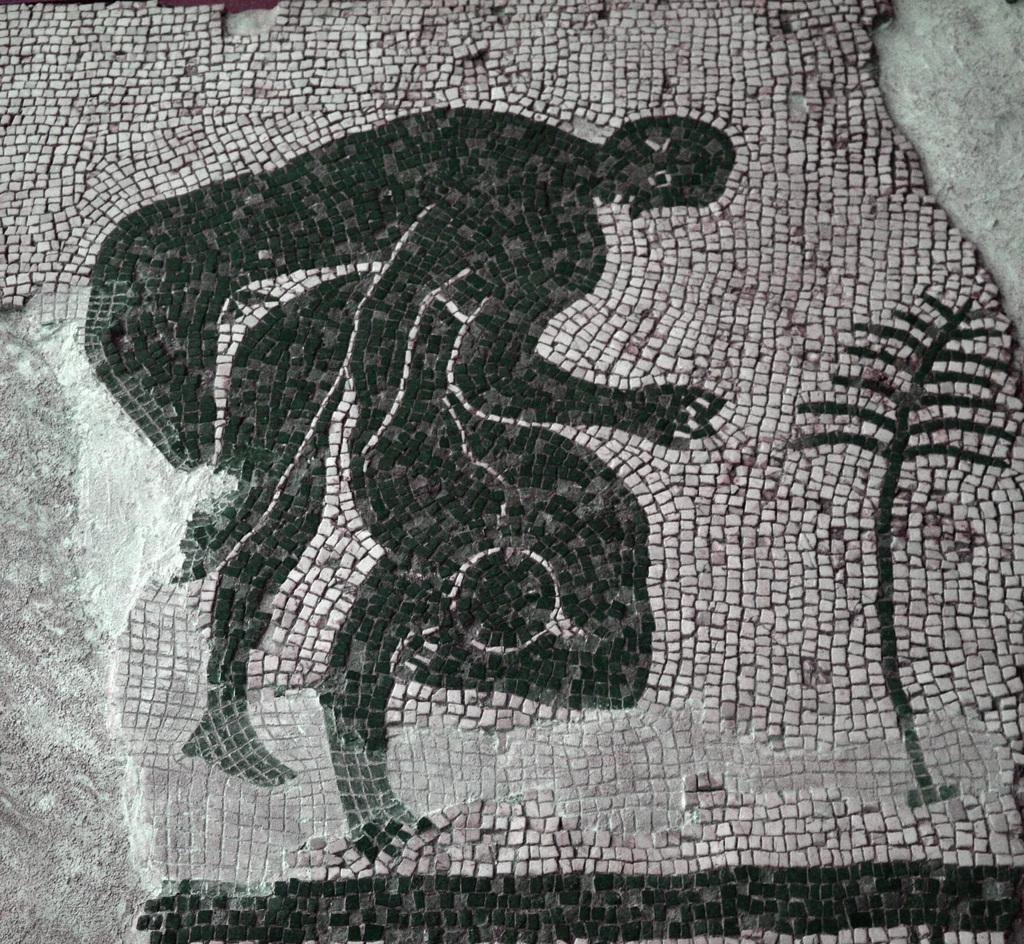What type of surface is visible in the image? There is a floor in the image. What is unique about the floor in the image? The floor has pictures painted on it. What type of friends can be seen playing with the apparatus in the image? There are no friends or apparatus present in the image; it only features a floor with pictures painted on it. 